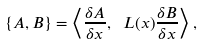Convert formula to latex. <formula><loc_0><loc_0><loc_500><loc_500>\left \{ A , B \right \} = \left < \frac { \delta A } { \delta x } , \ L ( x ) \frac { \delta B } { \delta x } \right > ,</formula> 